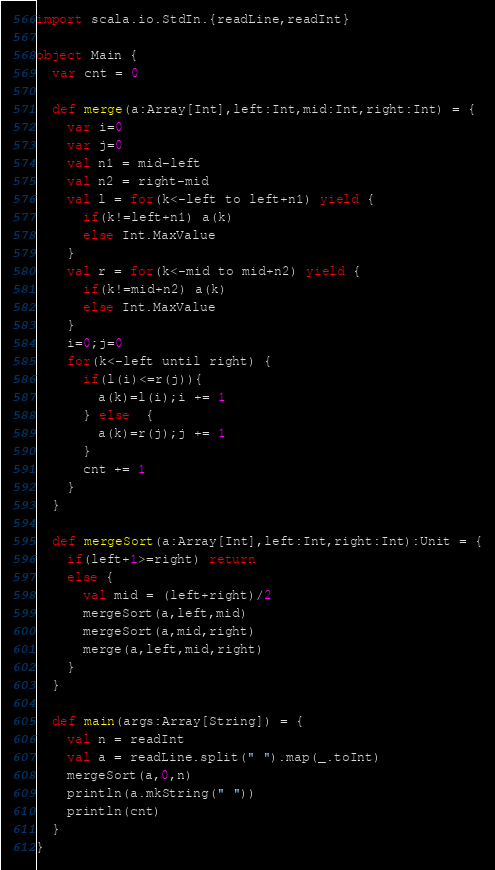Convert code to text. <code><loc_0><loc_0><loc_500><loc_500><_Scala_>import scala.io.StdIn.{readLine,readInt}

object Main {
  var cnt = 0

  def merge(a:Array[Int],left:Int,mid:Int,right:Int) = {
    var i=0
    var j=0
    val n1 = mid-left
    val n2 = right-mid
    val l = for(k<-left to left+n1) yield {
      if(k!=left+n1) a(k)
      else Int.MaxValue
    }
    val r = for(k<-mid to mid+n2) yield {
      if(k!=mid+n2) a(k)
      else Int.MaxValue
    }
    i=0;j=0
    for(k<-left until right) {
      if(l(i)<=r(j)){
        a(k)=l(i);i += 1
      } else  {
        a(k)=r(j);j += 1
      }
      cnt += 1
    }
  }

  def mergeSort(a:Array[Int],left:Int,right:Int):Unit = {
    if(left+1>=right) return
    else {
      val mid = (left+right)/2
      mergeSort(a,left,mid)
      mergeSort(a,mid,right)
      merge(a,left,mid,right)
    }
  }

  def main(args:Array[String]) = {
    val n = readInt
    val a = readLine.split(" ").map(_.toInt)
    mergeSort(a,0,n)
    println(a.mkString(" "))
    println(cnt)
  }
}</code> 